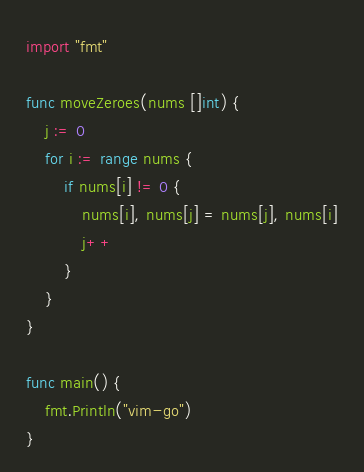Convert code to text. <code><loc_0><loc_0><loc_500><loc_500><_Go_>import "fmt"

func moveZeroes(nums []int) {
	j := 0
	for i := range nums {
		if nums[i] != 0 {
			nums[i], nums[j] = nums[j], nums[i]
			j++
		}
	}
}

func main() {
	fmt.Println("vim-go")
}
</code> 